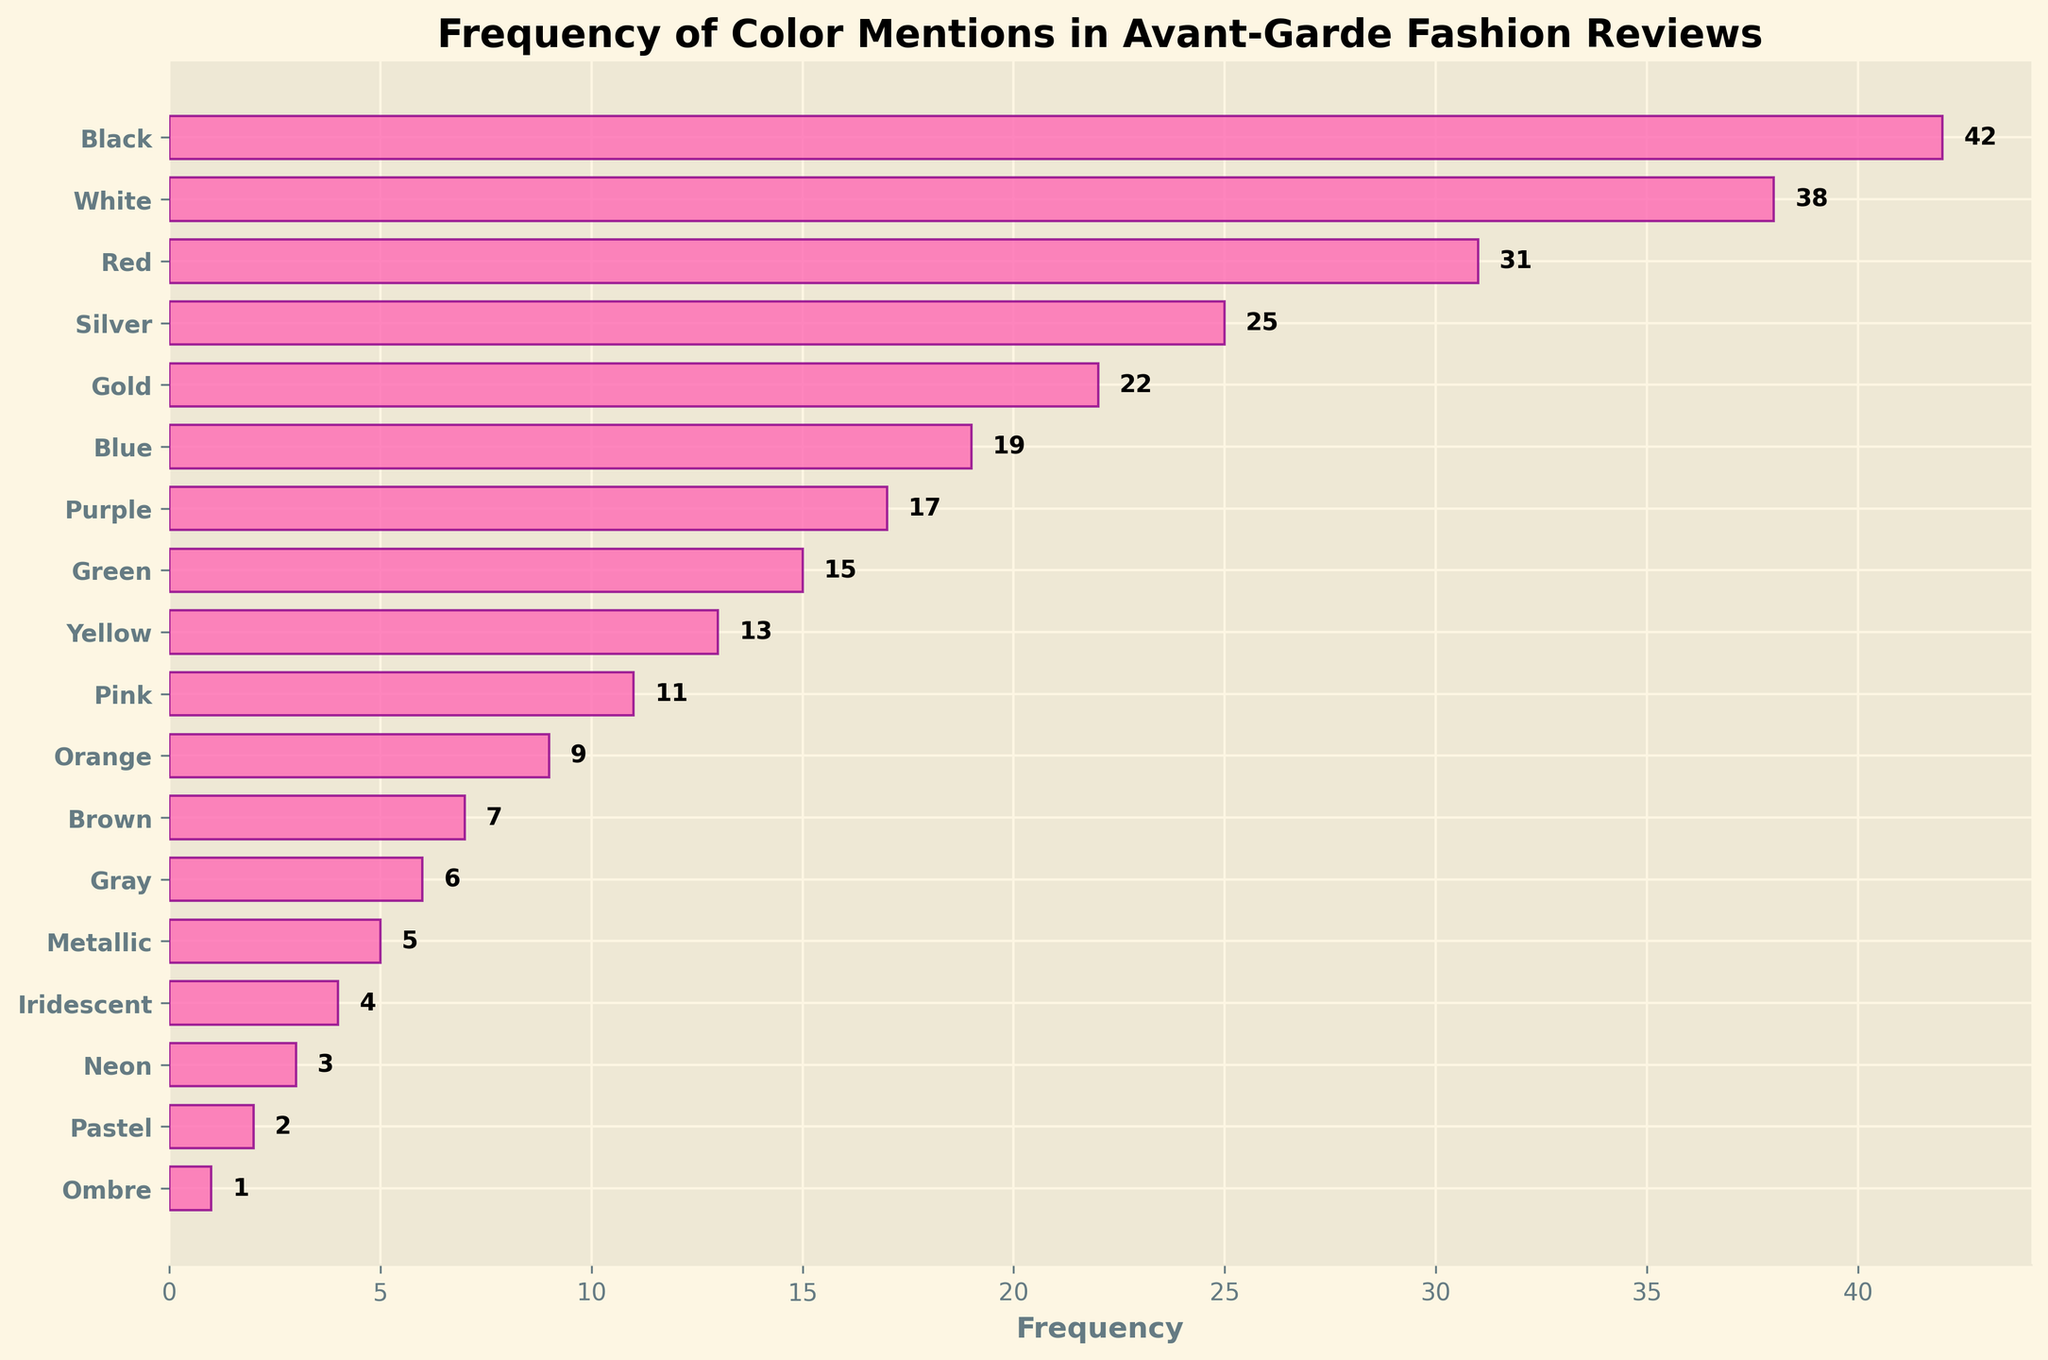What is the title of the figure? The title of a figure is usually placed at the top and is often in a larger and bolder font. The title in this figure is explicitly mentioned.
Answer: Frequency of Color Mentions in Avant-Garde Fashion Reviews Which color has the highest frequency? The horizontal density plot orders the colors based on their frequency, with the highest bar representing the most frequent color mention. The first color listed on the y-axis is "Black," and the corresponding bar is the longest.
Answer: Black How many colors are mentioned in the figure? The number of colors can be determined by counting the distinct labels on the y-axis. Each label corresponds to a different color. There are 18 labels.
Answer: 18 What is the combined frequency of Red, Blue, and Pink? To find the combined frequencies, locate the bars corresponding to Red, Blue, and Pink, and sum their frequencies. Red: 31, Blue: 19, Pink: 11. The sum = 31 + 19 + 11.
Answer: 61 Which color has a frequency of 7? Locate the bar that has a length representing a frequency of 7. The label corresponding to this bar is "Brown."
Answer: Brown Is Gold mentioned more frequently than Silver? Compare the lengths of the bars for Gold and Silver. The bar for Silver is longer than the bar for Gold, indicating more mentions. Silver's frequency is 25, and Gold's is 22.
Answer: No What is the frequency difference between White and Metallic colors? Subtract the frequency of Metallic from the frequency of White. White: 38, Metallic: 5. The difference = 38 - 5.
Answer: 33 What is the average frequency of the top three most mentioned colors? Identify the top three colors, which are Black (42), White (38), and Red (31). Calculate the average by summing their frequencies and dividing by three: (42 + 38 + 31) / 3.
Answer: 37 Are there any metallic-related colors, and how frequently are they mentioned? Look for colors related to metals or metallic properties in the labels. "Silver," "Gold," and "Metallic" fit this description. Sum their frequencies: Silver (25), Gold (22), Metallic (5). The combined frequency = 25 + 22 + 5.
Answer: 52 What is the least mentioned color, and what is its frequency? The least mentioned color is represented by the shortest bar. This belongs to "Ombre" with a frequency of 1.
Answer: Ombre, 1 